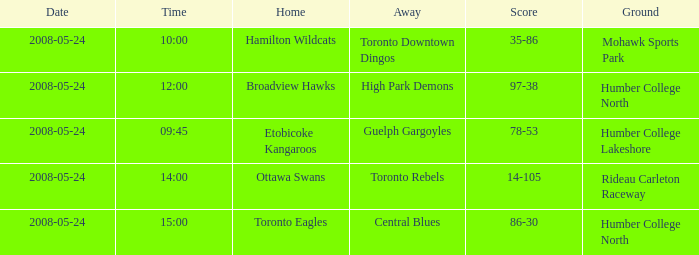Who was the home team of the game at the time of 15:00? Toronto Eagles. 